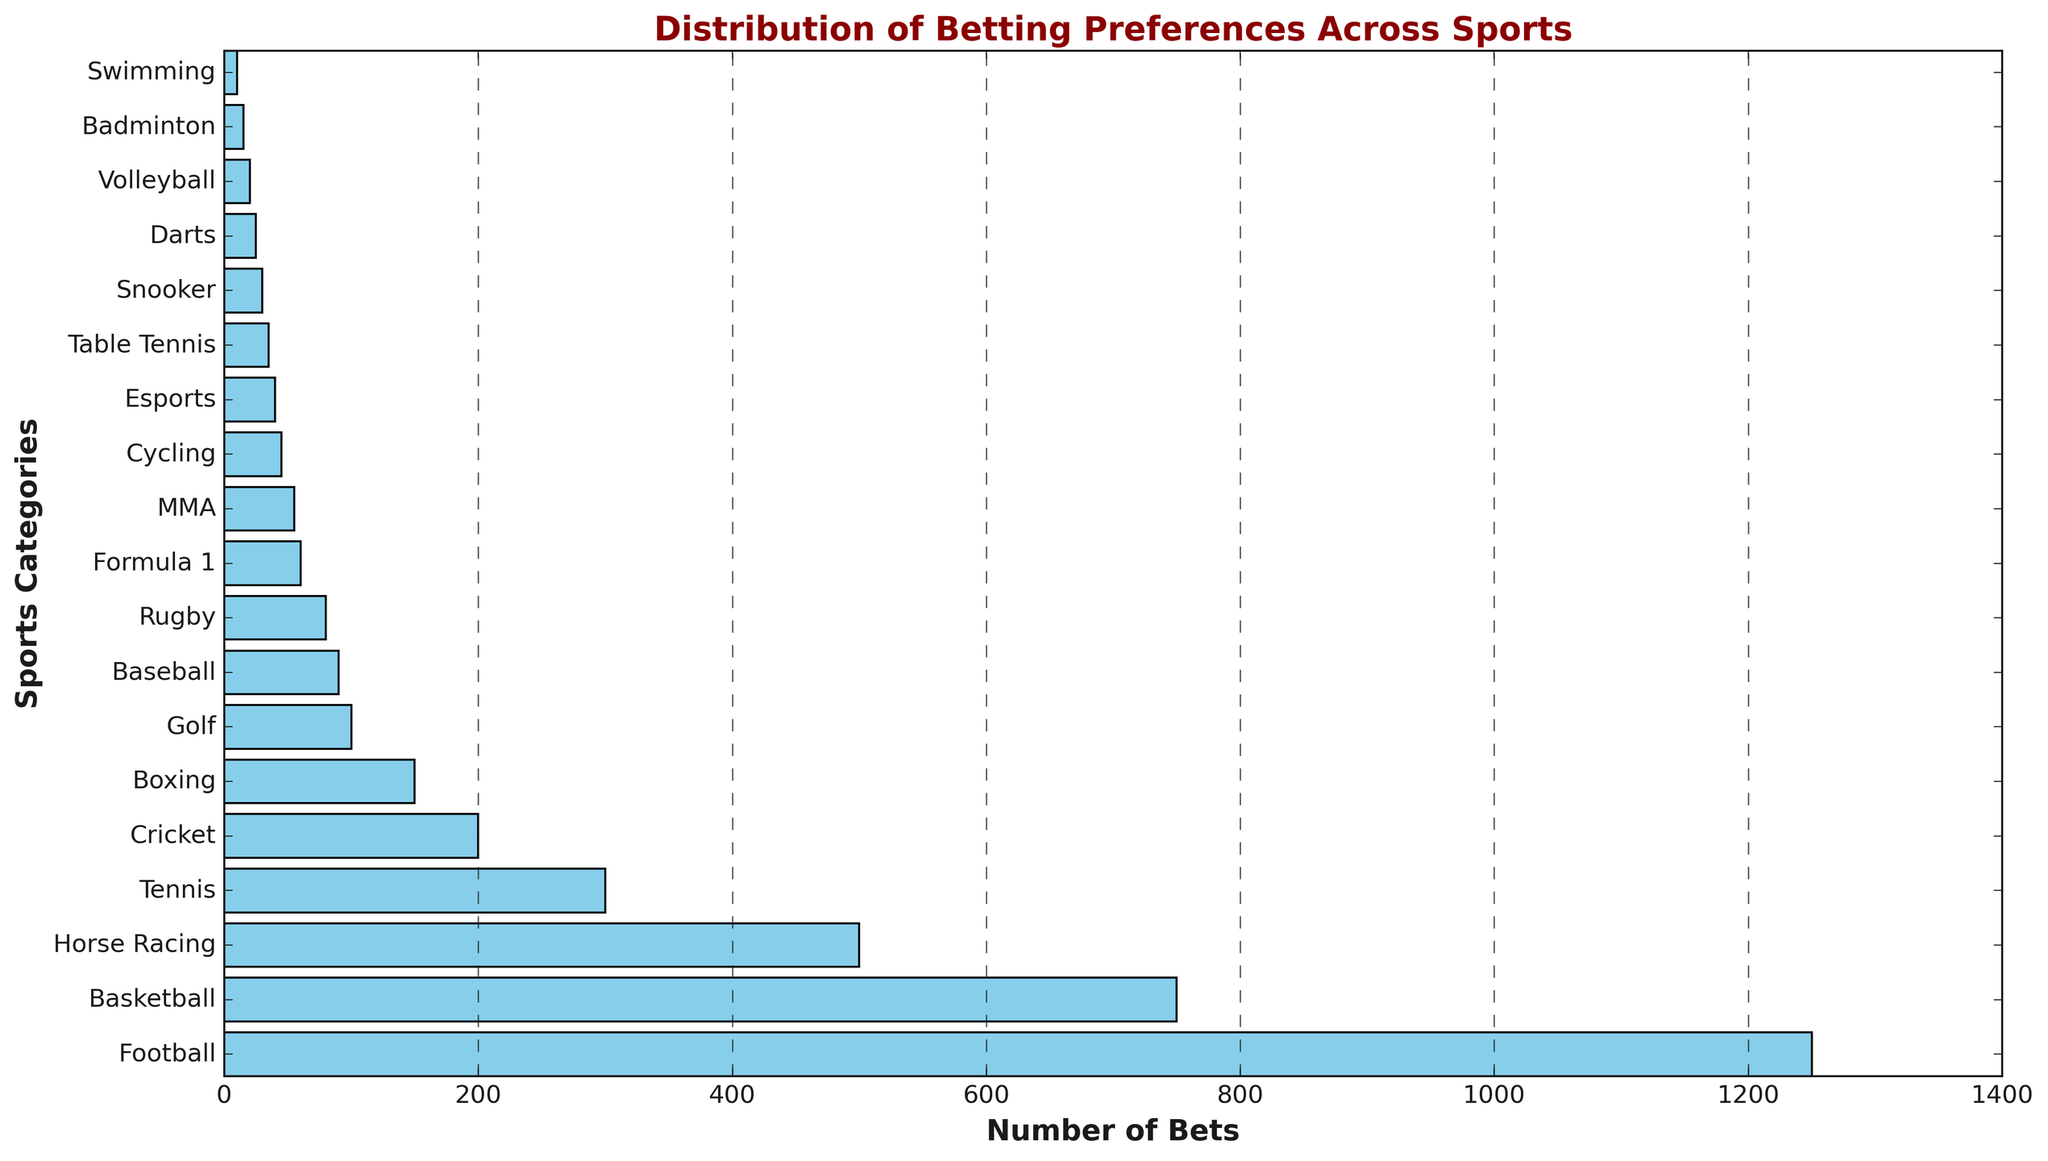Which sport has the highest number of bets? By looking at the bar with the longest length, we can see that it represents Football with 1250 bets
Answer: Football How many more bets does Football have compared to Esports? From the figure, Football has 1250 bets and Esports has 40 bets. Subtract the number of bets for Esports from the number for Football: 1250 - 40 = 1210
Answer: 1210 What is the total number of bets placed on Tennis and Cricket combined? From the figure, Tennis has 300 bets and Cricket has 200 bets. Add these two numbers together: 300 + 200 = 500
Answer: 500 Which sport has fewer bets: Basketball or Horse Racing? By comparing the length of the bars, Basketball has 750 bets and Horse Racing has 500 bets. Horse Racing has fewer bets
Answer: Horse Racing How many more bets does Basketball have compared to Rugby? From the figure, Basketball has 750 bets and Rugby has 80 bets. Subtract the number of bets for Rugby from the number for Basketball: 750 - 80 = 670
Answer: 670 What is the total number of bets placed on the sports categories with fewer than 50 bets each? From the figure, the sports with fewer than 50 bets are Cycling (45), Esports (40), Table Tennis (35), Snooker (30), Darts (25), Volleyball (20), Badminton (15), and Swimming (10). Adding these together: 45 + 40 + 35 + 30 + 25 + 20 + 15 + 10 = 220
Answer: 220 Which sports have equal betting numbers? From the figure, there are no bars of exactly the same length, hence no sports categories have the same number of bets
Answer: None What's the difference in the number of bets between the sport with the least bets and the sport with the most bets? The sport with the most bets is Football (1250 bets) and the least is Swimming (10 bets). Subtract the number of bets for Swimming from the number for Football: 1250 - 10 = 1240
Answer: 1240 Which sports category has the least number of bets? By looking at the bar with the shortest length, we can see that it represents Swimming with 10 bets
Answer: Swimming 